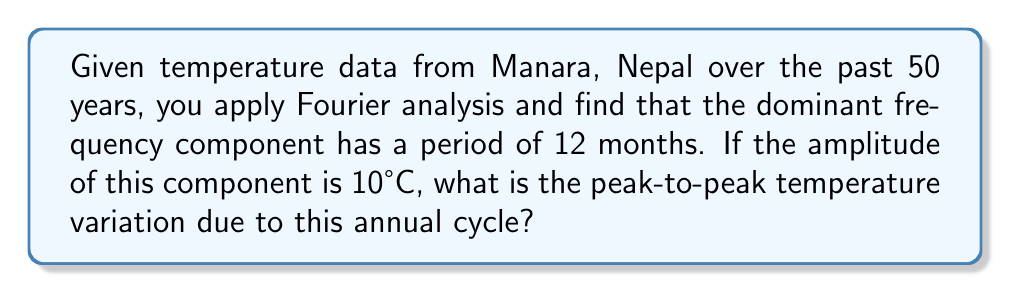What is the answer to this math problem? Let's approach this step-by-step:

1) In Fourier analysis, a periodic signal can be represented as a sum of sinusoidal components. The dominant frequency component with a 12-month period represents the annual temperature cycle.

2) The general form of a sinusoidal function is:

   $$T(t) = A \sin(2\pi ft + \phi)$$

   where $A$ is the amplitude, $f$ is the frequency, $t$ is time, and $\phi$ is the phase shift.

3) We're given that the amplitude $A$ is 10°C. This represents half of the peak-to-peak variation.

4) In a full sinusoidal cycle, the function goes from its minimum value $-A$ to its maximum value $A$. 

5) The peak-to-peak variation is the difference between the maximum and minimum values:

   $$\text{Peak-to-peak variation} = A - (-A) = 2A$$

6) Substituting the given amplitude:

   $$\text{Peak-to-peak variation} = 2 \times 10°C = 20°C$$

Therefore, the peak-to-peak temperature variation due to the annual cycle is 20°C.
Answer: 20°C 